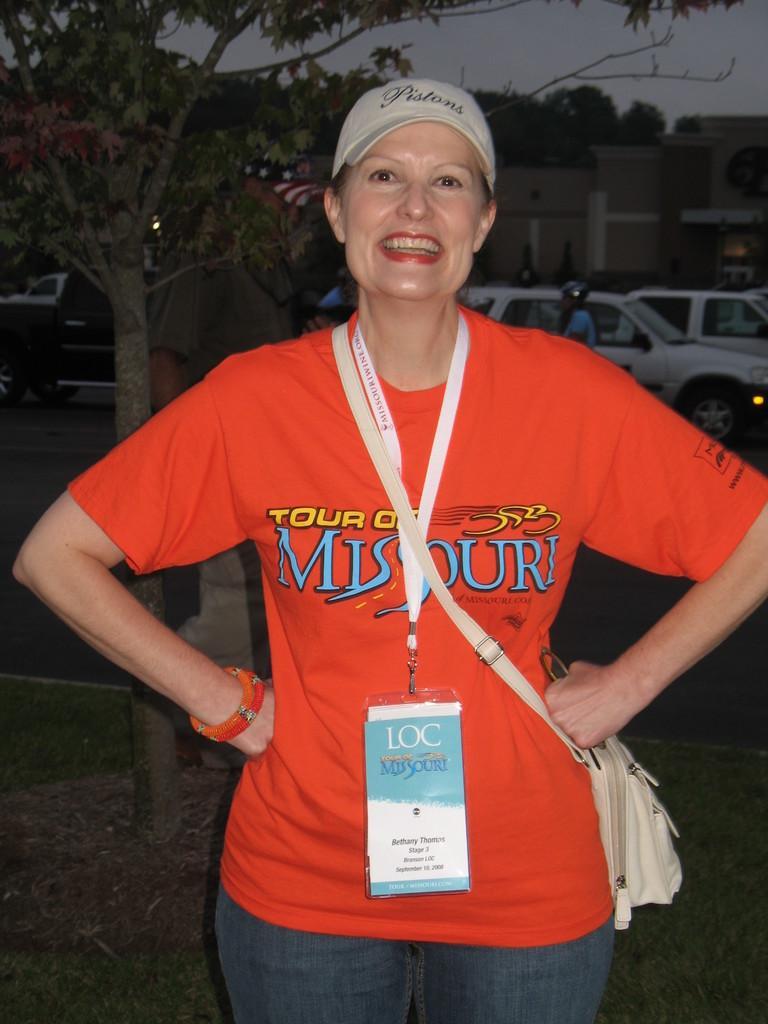Could you give a brief overview of what you see in this image? In this image we can see a woman smiling and wearing a sling bag. In the background we can see trees, sky, buildings and motor vehicles. 